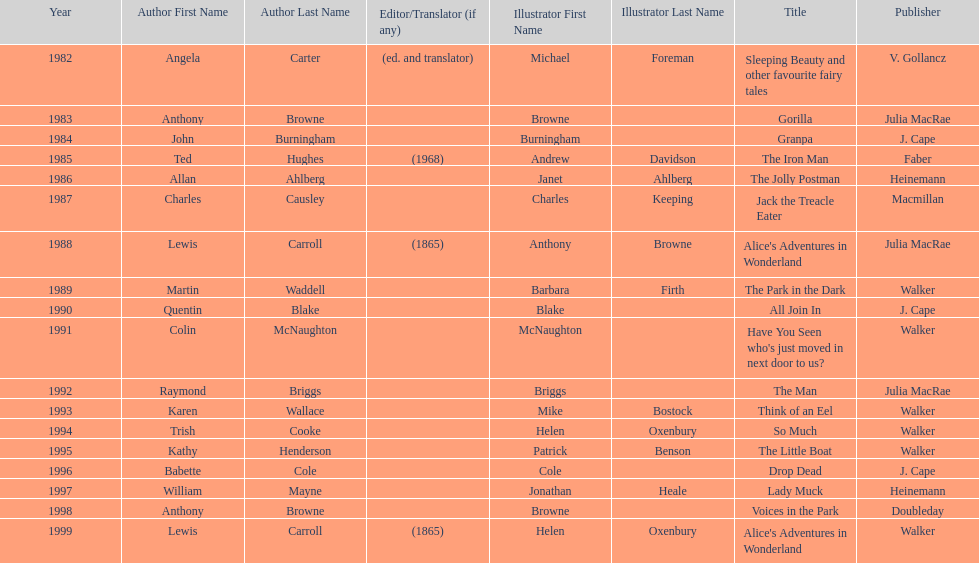Which other author, besides lewis carroll, has won the kurt maschler award twice? Anthony Browne. 